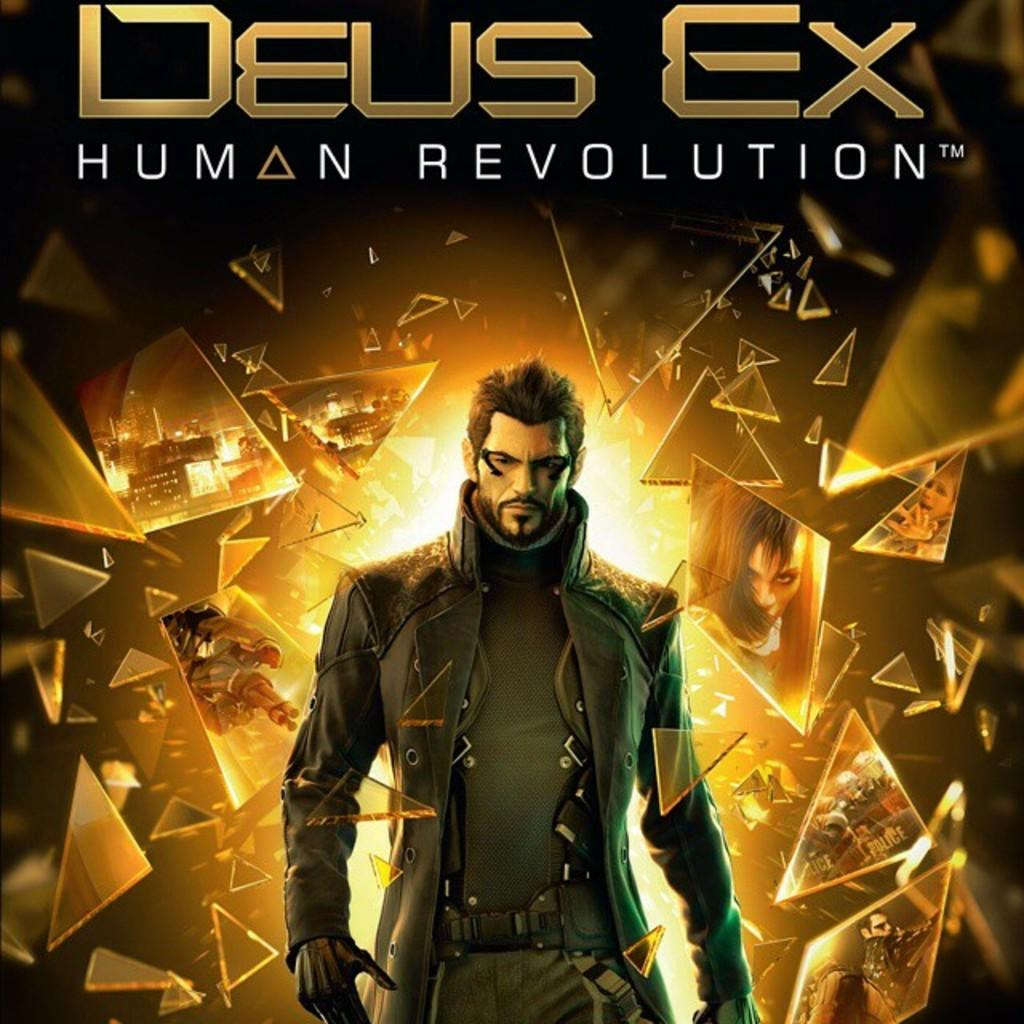<image>
Write a terse but informative summary of the picture. A cover advertising called Deus Ex Human Revolution. 